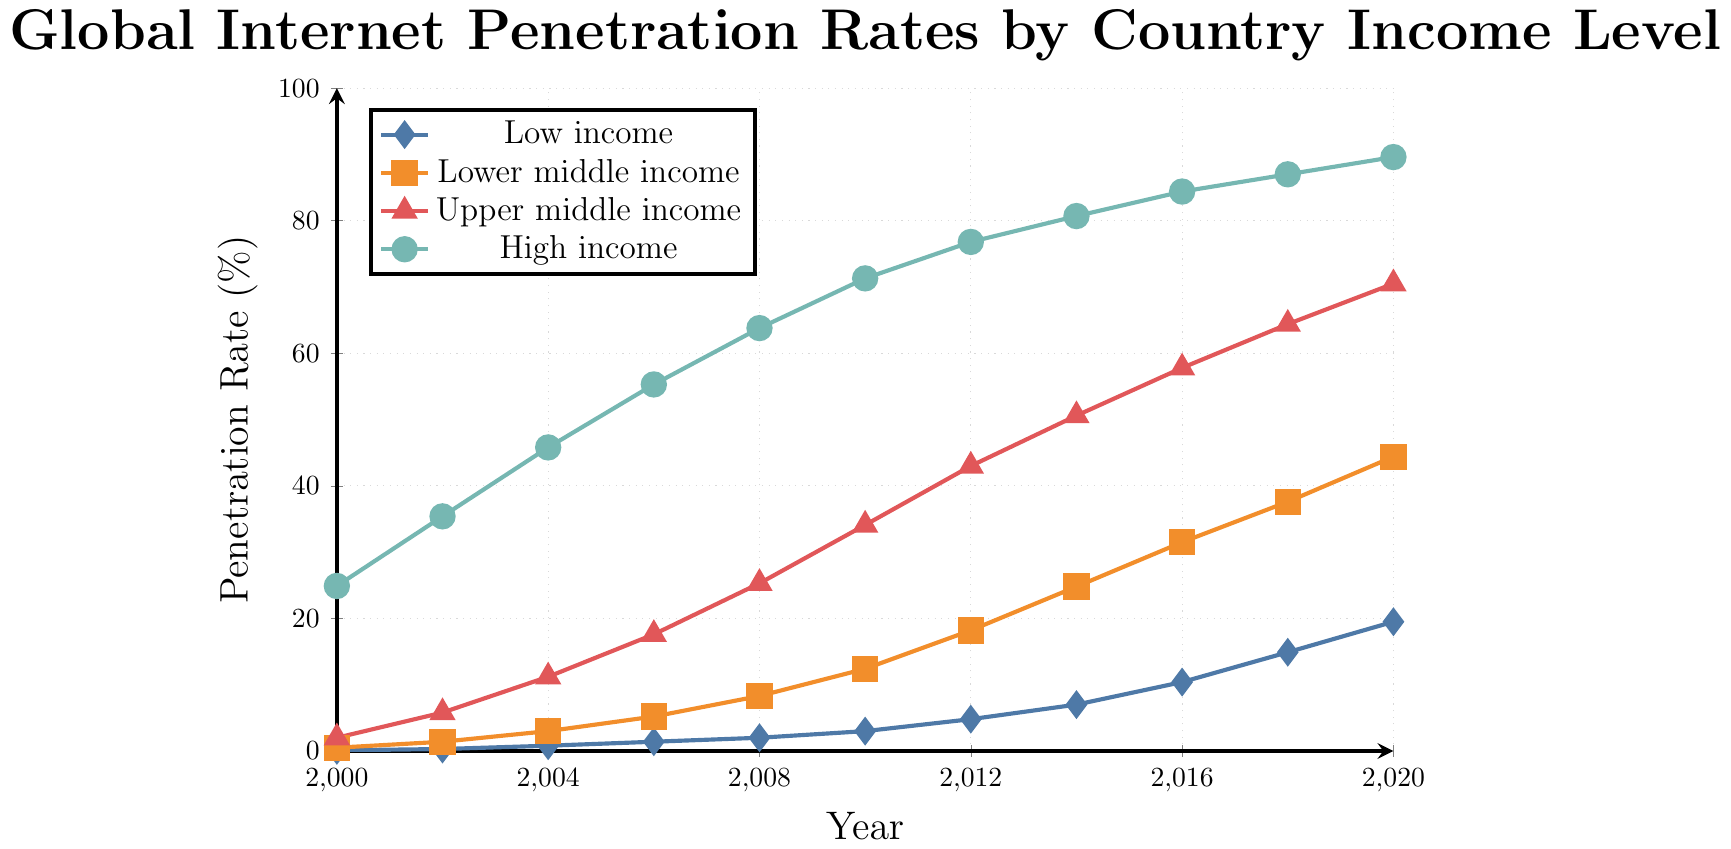What is the internet penetration rate for high-income countries in the year 2010? Look at the point on the high-income line (marked with circles) corresponding to the year 2010.
Answer: 71.3% Which income level had the largest increase in internet penetration rate between 2000 and 2020? Calculate the difference between the rates in 2020 and 2000 for each income level: 
Low income: 19.5 - 0.1 = 19.4 
Lower middle income: 44.4 - 0.5 = 43.9 
Upper middle income: 70.5 - 2.0 = 68.5 
High income: 89.6 - 24.9 = 64.7 
The upper middle income level had the largest increase.
Answer: Upper middle income In 2016, which income level had the lowest internet penetration rate, and what was it? Compare the internet penetration rates for all income levels in 2016 and identify the lowest one by looking at the height of the lines in the plot for that year.
Answer: Low income, 10.4% By how much did the internet penetration rate for lower-middle-income countries increase from 2002 to 2012? Subtract the rate in 2002 from the rate in 2012: 18.2 - 1.4 = 16.8.
Answer: 16.8% How does the internet penetration rate for upper-middle-income countries in 2006 compare to that of low-income countries in 2016? Identify the rate for upper-middle-income countries in 2006 (17.6) and low-income countries in 2016 (10.4). Compare the two values.
Answer: Higher What is the general trend of internet penetration rates for high-income countries over the past two decades? Observe the slope and direction of the line representing high-income countries from 2000 to 2020. The line steadily increases over time, indicating a consistent upward trend.
Answer: Increasing What was the penetration rate difference between upper middle income and lower middle income countries in 2014? Subtract the lower middle income rate from the upper middle income rate for the year 2014: 50.6 - 24.8 = 25.8.
Answer: 25.8 Which year saw the first time that the internet penetration rate for high-income countries exceeded 80%? Identify the point on the high-income line that first crosses 80%, which is in 2014.
Answer: 2014 When did the internet penetration rate for low-income countries first reach double digits? Find the point on the low-income line where the rate first reaches or exceeds 10%. This happens in 2016.
Answer: 2016 